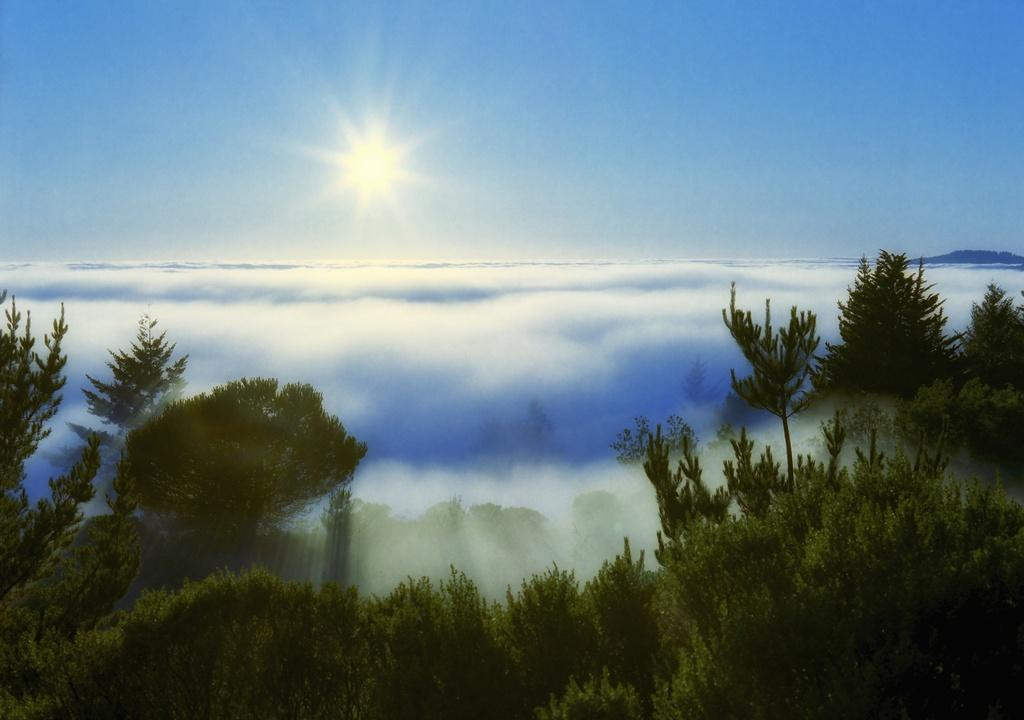What type of vegetation is at the bottom of the image? There are trees at the bottom of the image. What can be seen in the middle of the image? There are clouds in the middle of the image. What is the source of light in the image? Sunlight is visible in the image. What is visible at the top of the image? The sky is visible at the top of the image. What part of the discussion is being held in the image? There is no discussion present in the image; it features trees, clouds, sunlight, and the sky. How does the roll of paper contribute to the image? There is no roll of paper present in the image. 